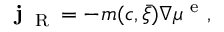Convert formula to latex. <formula><loc_0><loc_0><loc_500><loc_500>{ j } _ { R } = - m ( c , \bar { \xi } ) \nabla \mu ^ { e } ,</formula> 